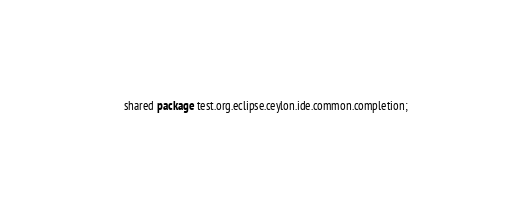<code> <loc_0><loc_0><loc_500><loc_500><_Ceylon_>shared package test.org.eclipse.ceylon.ide.common.completion;
</code> 